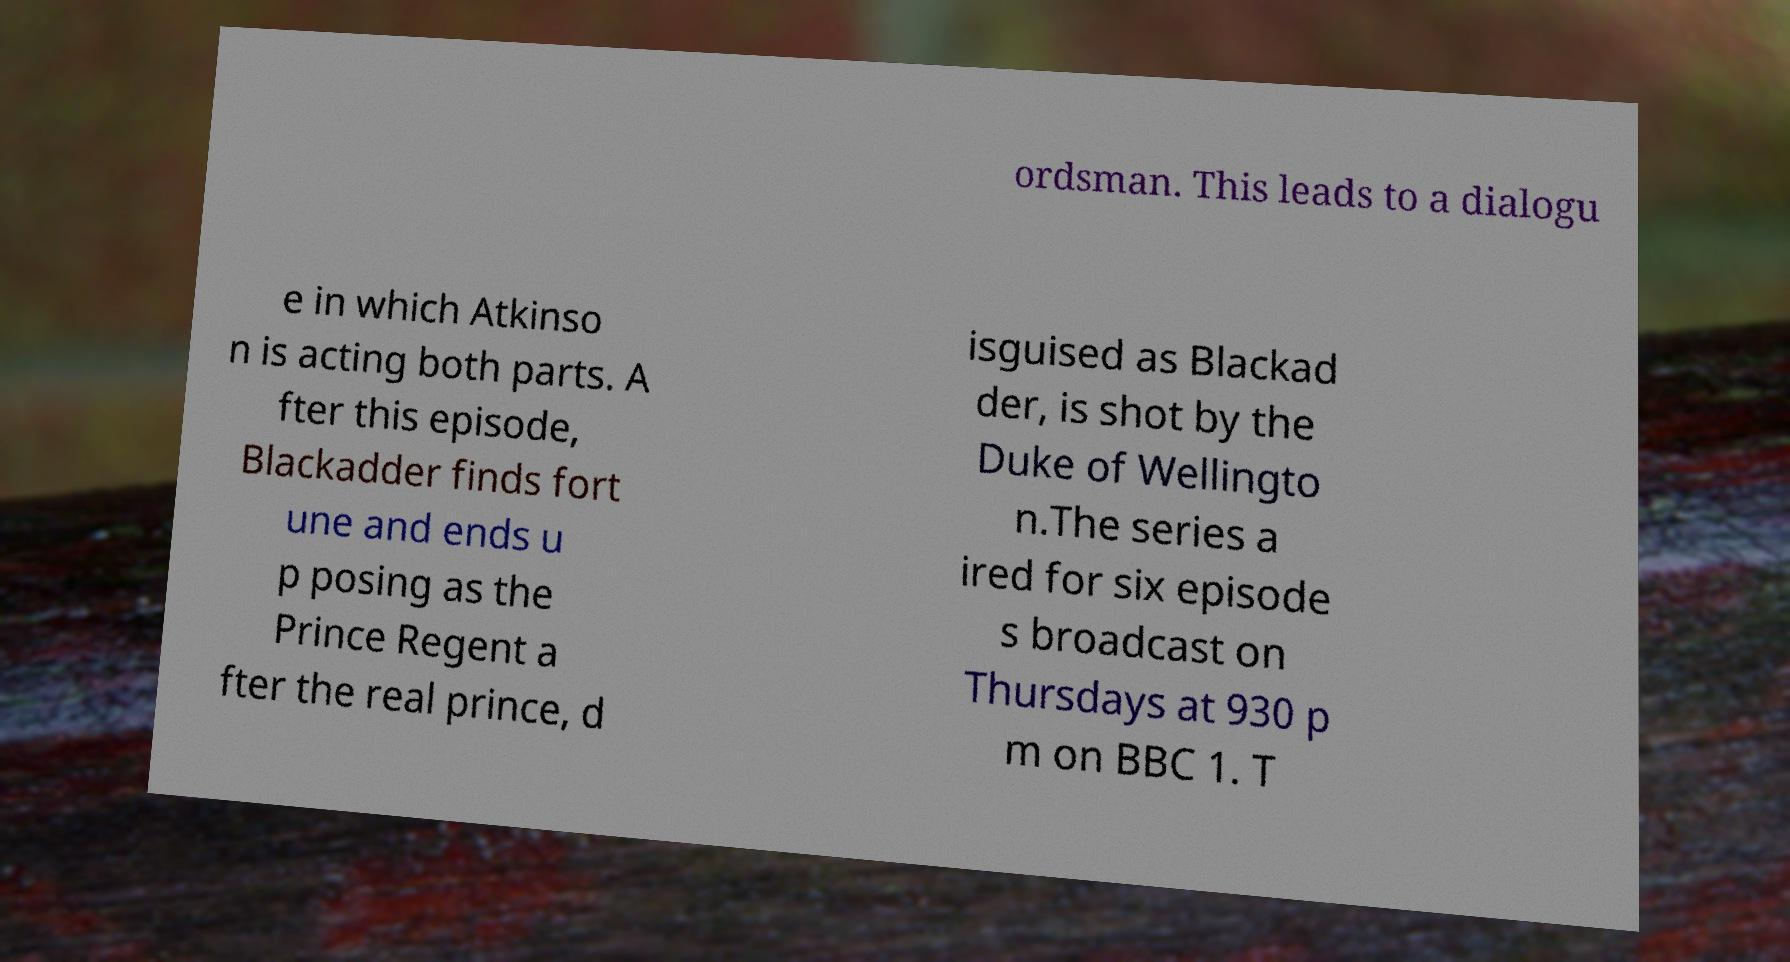There's text embedded in this image that I need extracted. Can you transcribe it verbatim? ordsman. This leads to a dialogu e in which Atkinso n is acting both parts. A fter this episode, Blackadder finds fort une and ends u p posing as the Prince Regent a fter the real prince, d isguised as Blackad der, is shot by the Duke of Wellingto n.The series a ired for six episode s broadcast on Thursdays at 930 p m on BBC 1. T 